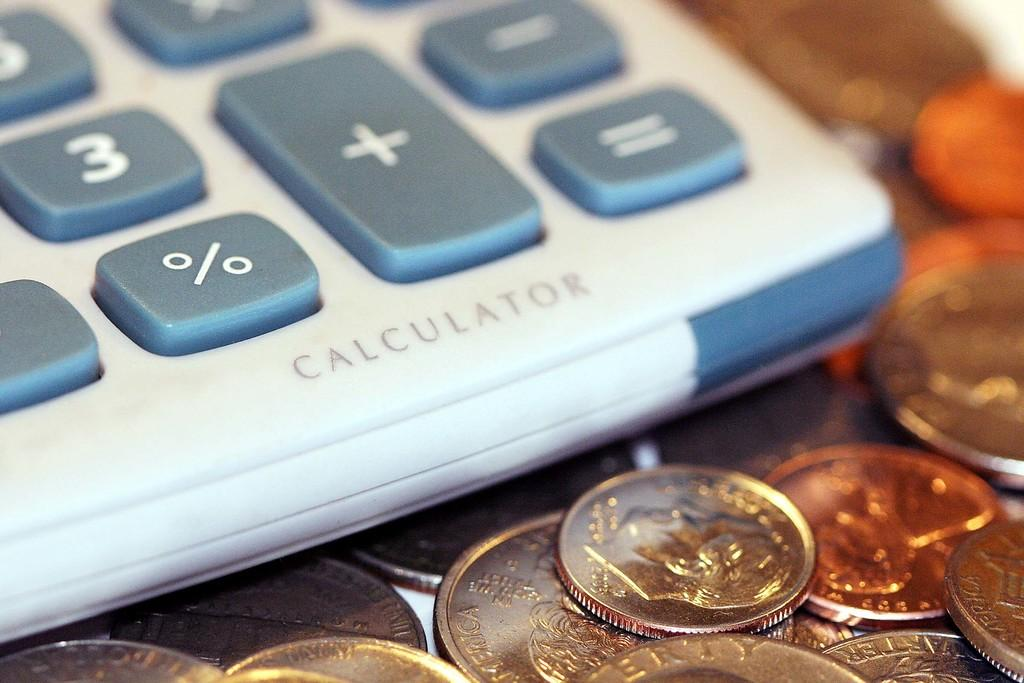What objects can be seen in the image? There are coins and a calculator in the image. What is the purpose of the calculator? The calculator is used for performing mathematical calculations. What can be found on the surface of the calculator? The calculator has numbers and symbols on it. What type of rhythm can be heard coming from the coins in the image? There is no sound or rhythm associated with the coins in the image. 